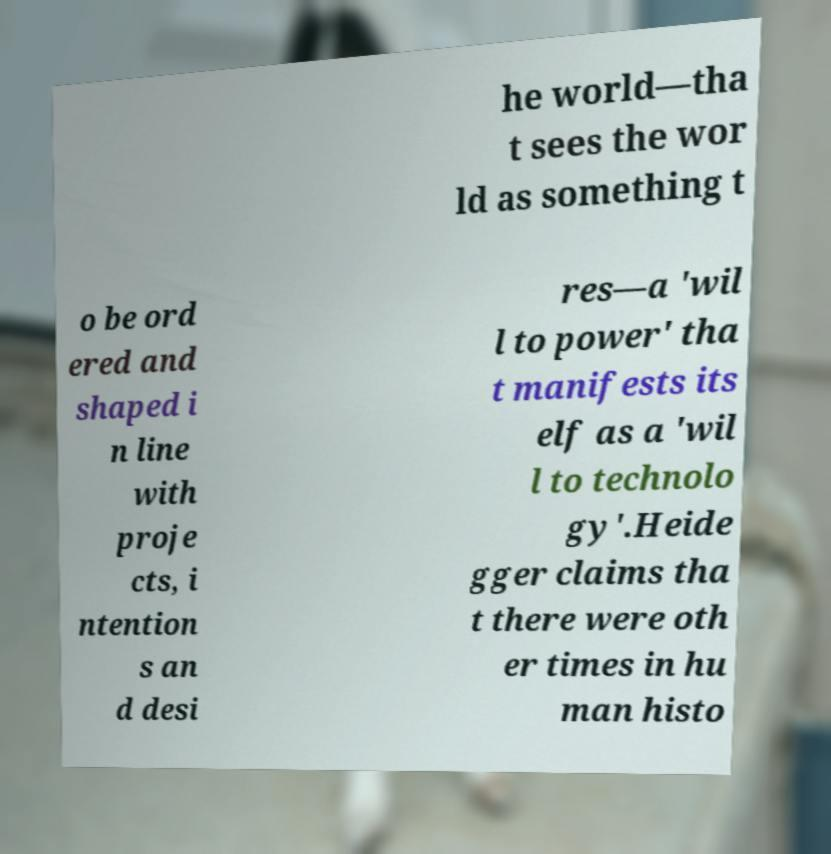Could you assist in decoding the text presented in this image and type it out clearly? he world—tha t sees the wor ld as something t o be ord ered and shaped i n line with proje cts, i ntention s an d desi res—a 'wil l to power' tha t manifests its elf as a 'wil l to technolo gy'.Heide gger claims tha t there were oth er times in hu man histo 